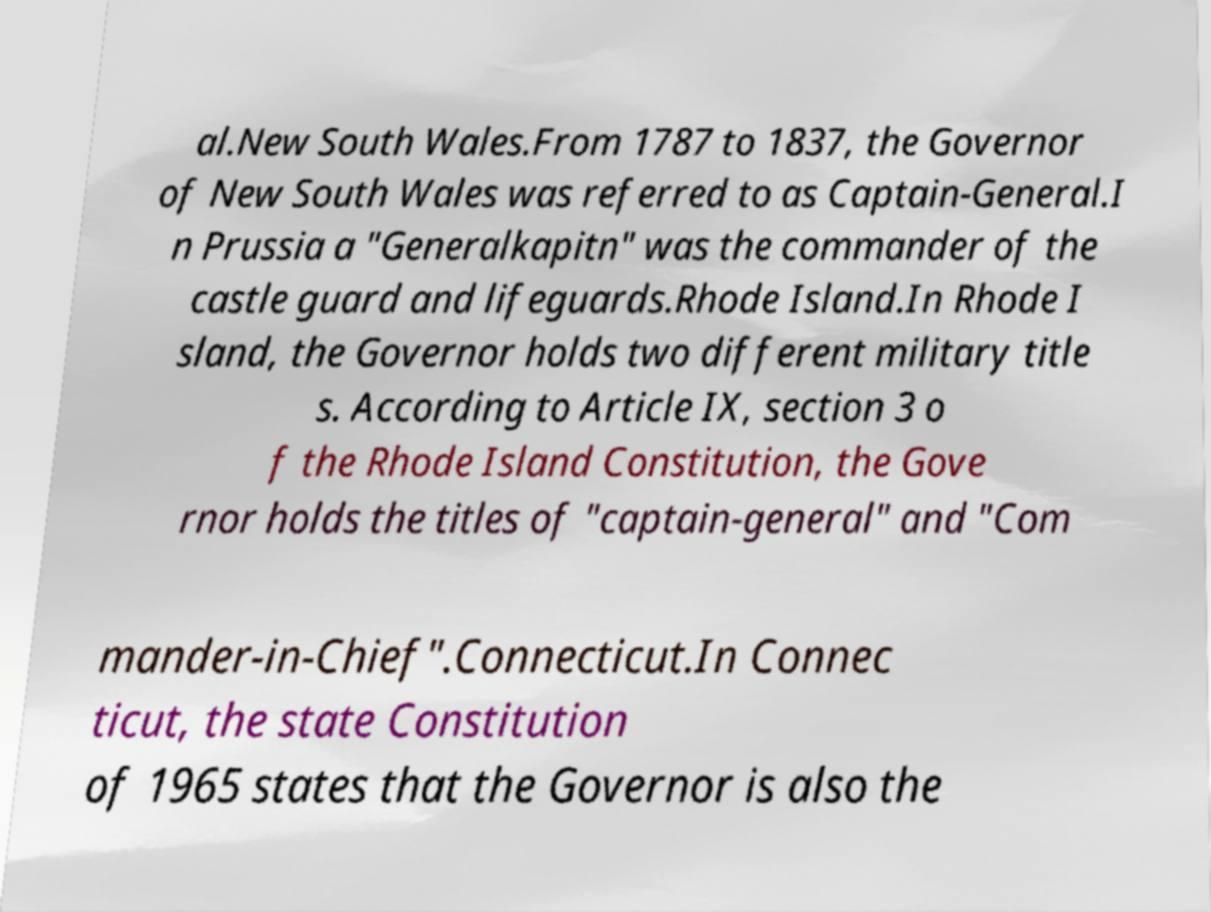Can you accurately transcribe the text from the provided image for me? al.New South Wales.From 1787 to 1837, the Governor of New South Wales was referred to as Captain-General.I n Prussia a "Generalkapitn" was the commander of the castle guard and lifeguards.Rhode Island.In Rhode I sland, the Governor holds two different military title s. According to Article IX, section 3 o f the Rhode Island Constitution, the Gove rnor holds the titles of "captain-general" and "Com mander-in-Chief".Connecticut.In Connec ticut, the state Constitution of 1965 states that the Governor is also the 